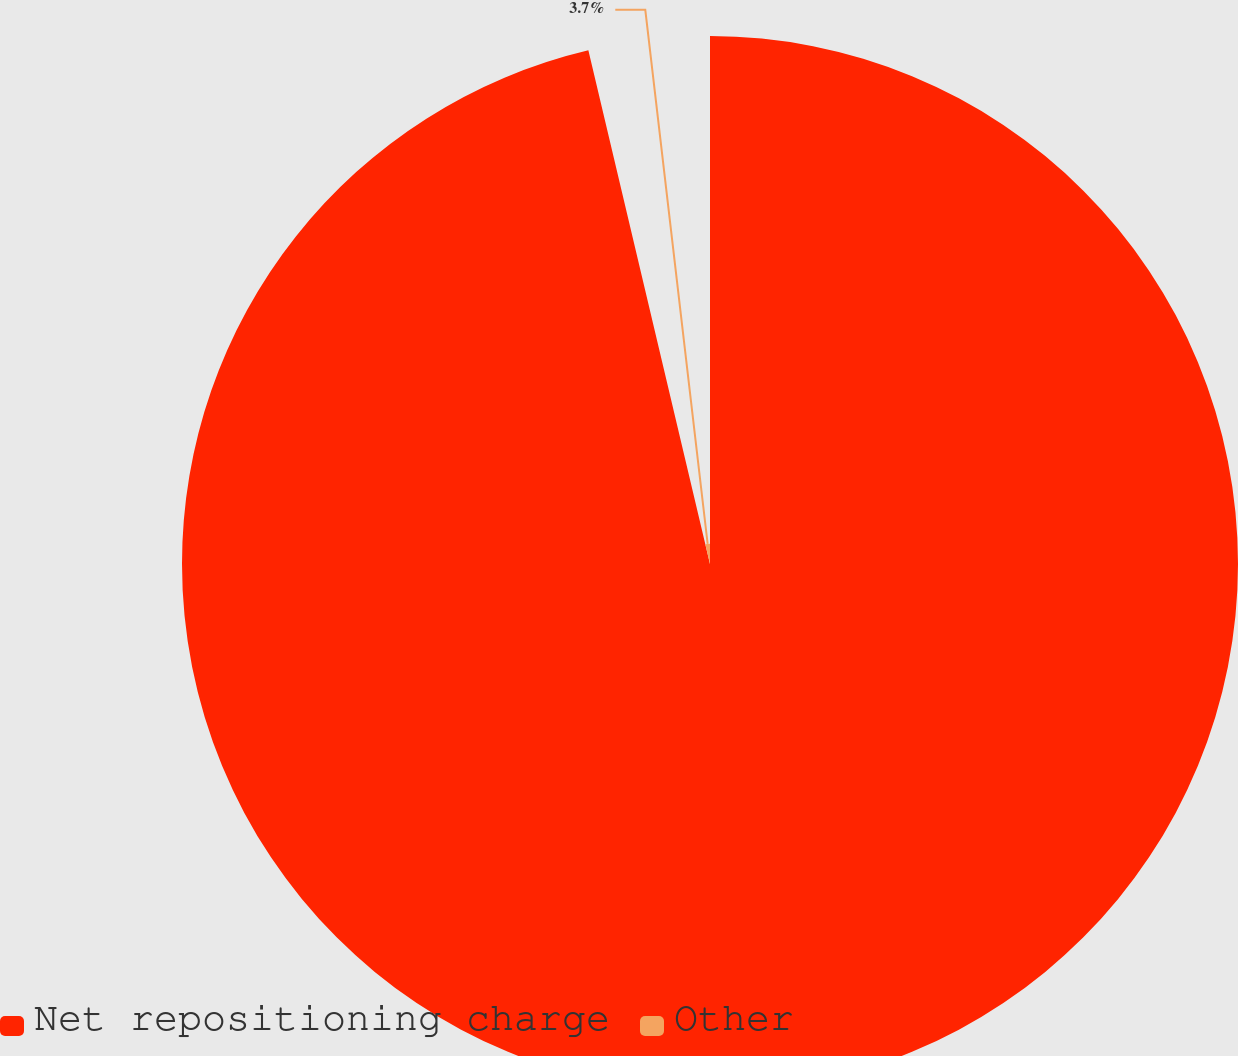Convert chart. <chart><loc_0><loc_0><loc_500><loc_500><pie_chart><fcel>Net repositioning charge<fcel>Other<nl><fcel>96.3%<fcel>3.7%<nl></chart> 